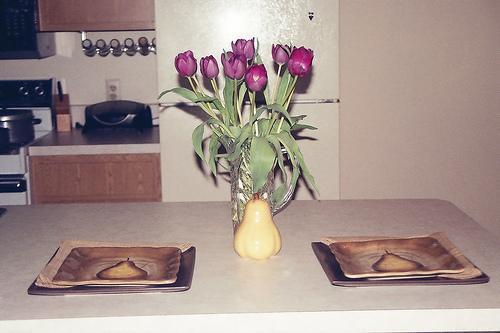How many flowers are there?
Give a very brief answer. 7. 